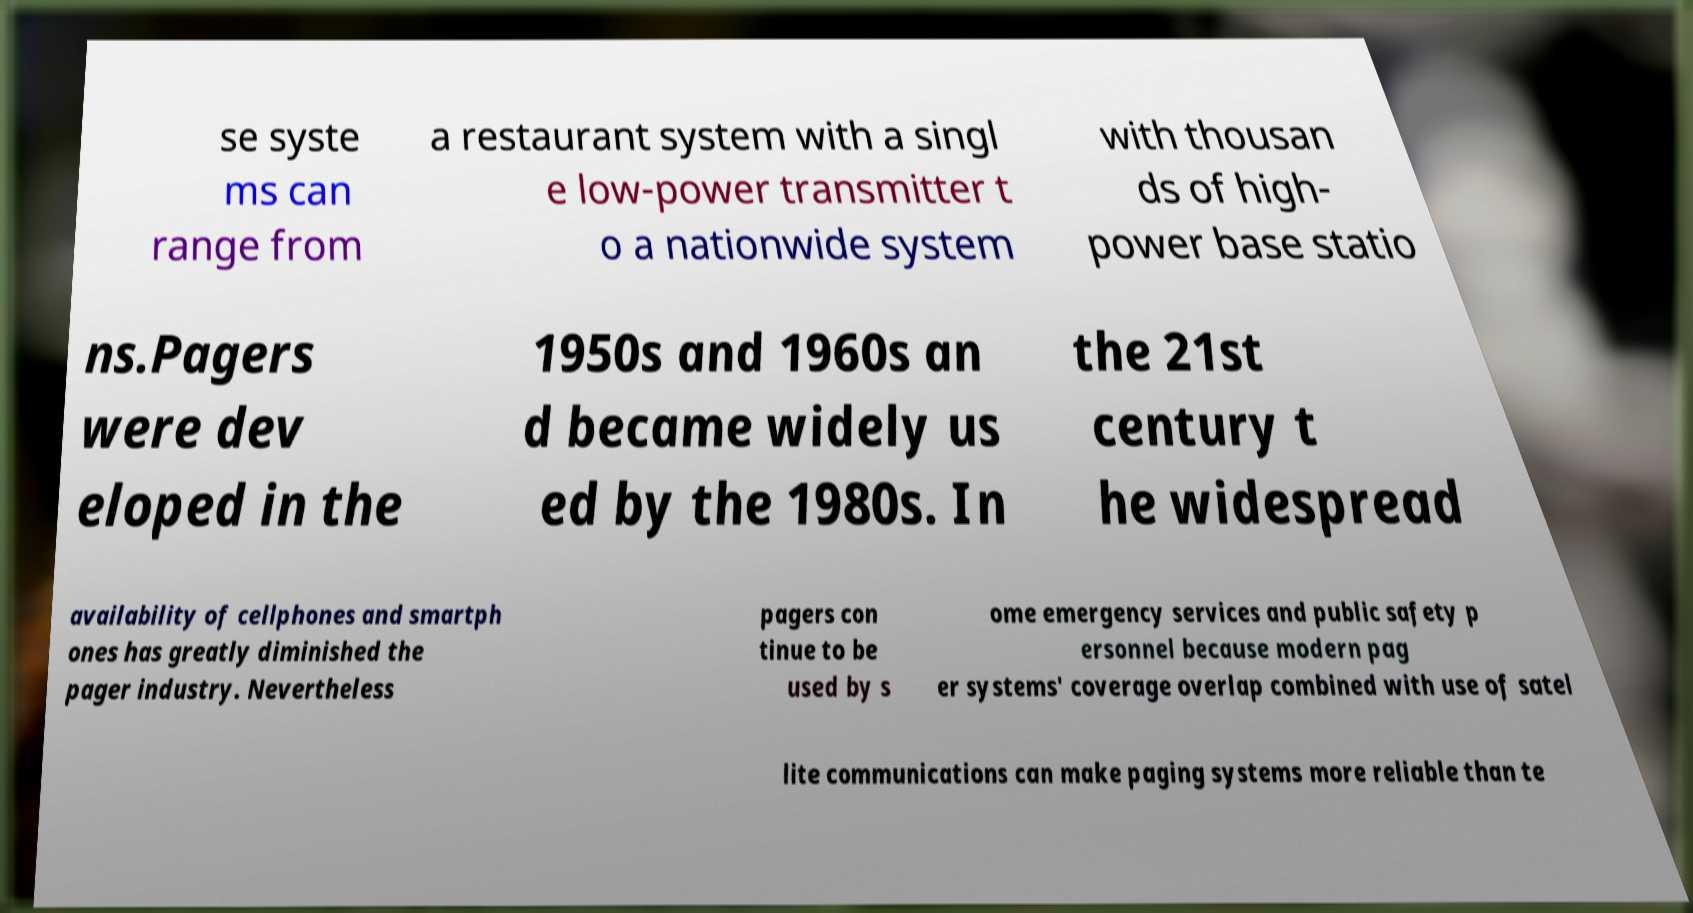Could you assist in decoding the text presented in this image and type it out clearly? se syste ms can range from a restaurant system with a singl e low-power transmitter t o a nationwide system with thousan ds of high- power base statio ns.Pagers were dev eloped in the 1950s and 1960s an d became widely us ed by the 1980s. In the 21st century t he widespread availability of cellphones and smartph ones has greatly diminished the pager industry. Nevertheless pagers con tinue to be used by s ome emergency services and public safety p ersonnel because modern pag er systems' coverage overlap combined with use of satel lite communications can make paging systems more reliable than te 